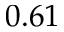<formula> <loc_0><loc_0><loc_500><loc_500>0 . 6 1</formula> 